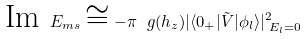Convert formula to latex. <formula><loc_0><loc_0><loc_500><loc_500>\text {Im } E _ { m s } \cong - \pi \ g ( h _ { z } ) | \langle 0 _ { + } | \tilde { V } | \phi _ { l } \rangle | _ { \text { } E _ { l } = 0 } ^ { 2 }</formula> 